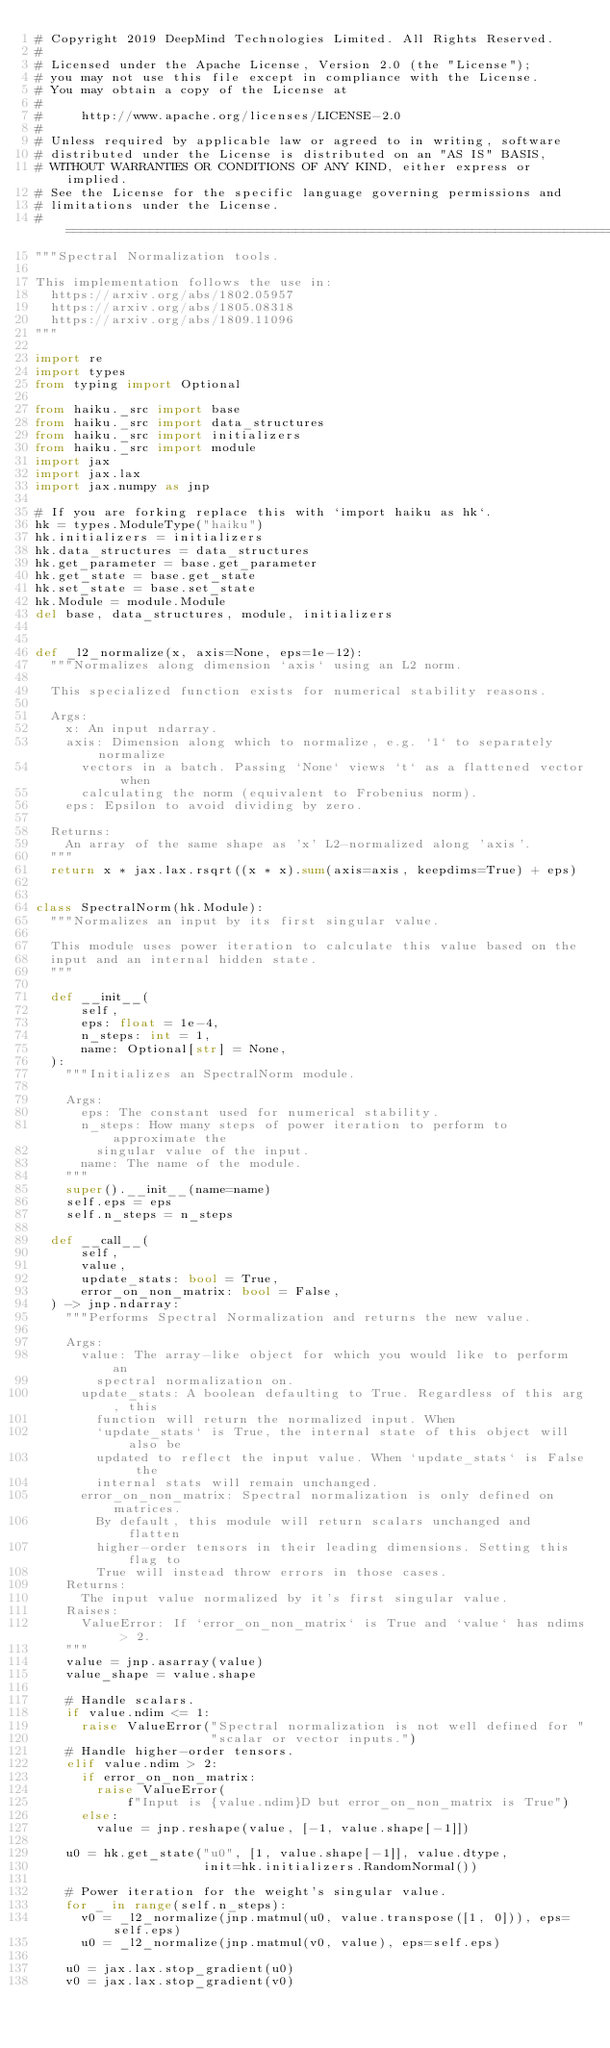<code> <loc_0><loc_0><loc_500><loc_500><_Python_># Copyright 2019 DeepMind Technologies Limited. All Rights Reserved.
#
# Licensed under the Apache License, Version 2.0 (the "License");
# you may not use this file except in compliance with the License.
# You may obtain a copy of the License at
#
#     http://www.apache.org/licenses/LICENSE-2.0
#
# Unless required by applicable law or agreed to in writing, software
# distributed under the License is distributed on an "AS IS" BASIS,
# WITHOUT WARRANTIES OR CONDITIONS OF ANY KIND, either express or implied.
# See the License for the specific language governing permissions and
# limitations under the License.
# ==============================================================================
"""Spectral Normalization tools.

This implementation follows the use in:
  https://arxiv.org/abs/1802.05957
  https://arxiv.org/abs/1805.08318
  https://arxiv.org/abs/1809.11096
"""

import re
import types
from typing import Optional

from haiku._src import base
from haiku._src import data_structures
from haiku._src import initializers
from haiku._src import module
import jax
import jax.lax
import jax.numpy as jnp

# If you are forking replace this with `import haiku as hk`.
hk = types.ModuleType("haiku")
hk.initializers = initializers
hk.data_structures = data_structures
hk.get_parameter = base.get_parameter
hk.get_state = base.get_state
hk.set_state = base.set_state
hk.Module = module.Module
del base, data_structures, module, initializers


def _l2_normalize(x, axis=None, eps=1e-12):
  """Normalizes along dimension `axis` using an L2 norm.

  This specialized function exists for numerical stability reasons.

  Args:
    x: An input ndarray.
    axis: Dimension along which to normalize, e.g. `1` to separately normalize
      vectors in a batch. Passing `None` views `t` as a flattened vector when
      calculating the norm (equivalent to Frobenius norm).
    eps: Epsilon to avoid dividing by zero.

  Returns:
    An array of the same shape as 'x' L2-normalized along 'axis'.
  """
  return x * jax.lax.rsqrt((x * x).sum(axis=axis, keepdims=True) + eps)


class SpectralNorm(hk.Module):
  """Normalizes an input by its first singular value.

  This module uses power iteration to calculate this value based on the
  input and an internal hidden state.
  """

  def __init__(
      self,
      eps: float = 1e-4,
      n_steps: int = 1,
      name: Optional[str] = None,
  ):
    """Initializes an SpectralNorm module.

    Args:
      eps: The constant used for numerical stability.
      n_steps: How many steps of power iteration to perform to approximate the
        singular value of the input.
      name: The name of the module.
    """
    super().__init__(name=name)
    self.eps = eps
    self.n_steps = n_steps

  def __call__(
      self,
      value,
      update_stats: bool = True,
      error_on_non_matrix: bool = False,
  ) -> jnp.ndarray:
    """Performs Spectral Normalization and returns the new value.

    Args:
      value: The array-like object for which you would like to perform an
        spectral normalization on.
      update_stats: A boolean defaulting to True. Regardless of this arg, this
        function will return the normalized input. When
        `update_stats` is True, the internal state of this object will also be
        updated to reflect the input value. When `update_stats` is False the
        internal stats will remain unchanged.
      error_on_non_matrix: Spectral normalization is only defined on matrices.
        By default, this module will return scalars unchanged and flatten
        higher-order tensors in their leading dimensions. Setting this flag to
        True will instead throw errors in those cases.
    Returns:
      The input value normalized by it's first singular value.
    Raises:
      ValueError: If `error_on_non_matrix` is True and `value` has ndims > 2.
    """
    value = jnp.asarray(value)
    value_shape = value.shape

    # Handle scalars.
    if value.ndim <= 1:
      raise ValueError("Spectral normalization is not well defined for "
                       "scalar or vector inputs.")
    # Handle higher-order tensors.
    elif value.ndim > 2:
      if error_on_non_matrix:
        raise ValueError(
            f"Input is {value.ndim}D but error_on_non_matrix is True")
      else:
        value = jnp.reshape(value, [-1, value.shape[-1]])

    u0 = hk.get_state("u0", [1, value.shape[-1]], value.dtype,
                      init=hk.initializers.RandomNormal())

    # Power iteration for the weight's singular value.
    for _ in range(self.n_steps):
      v0 = _l2_normalize(jnp.matmul(u0, value.transpose([1, 0])), eps=self.eps)
      u0 = _l2_normalize(jnp.matmul(v0, value), eps=self.eps)

    u0 = jax.lax.stop_gradient(u0)
    v0 = jax.lax.stop_gradient(v0)
</code> 